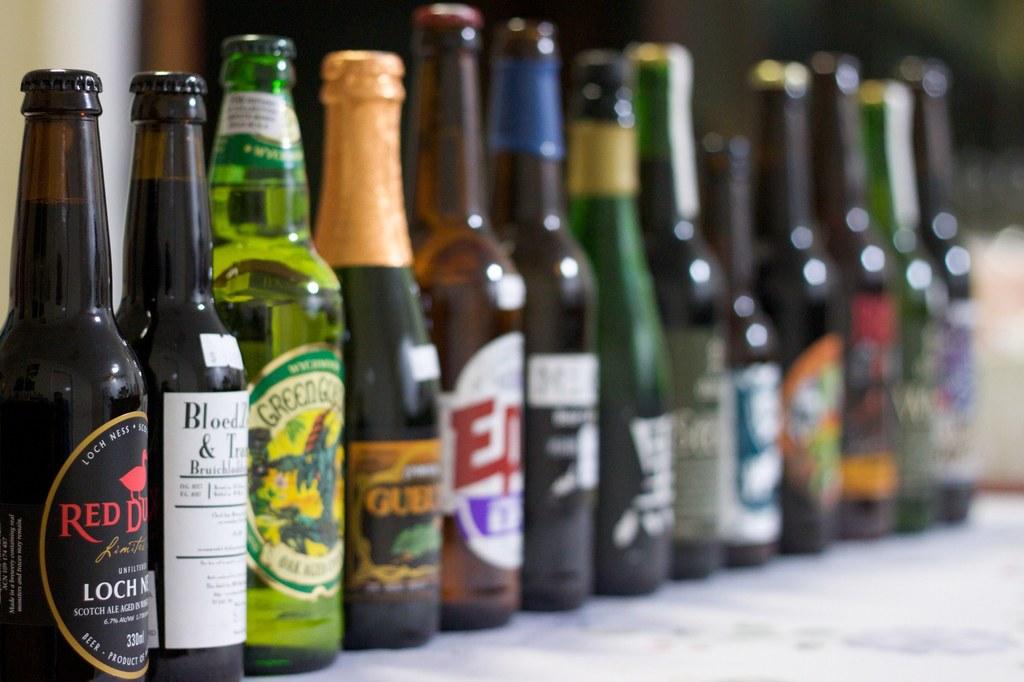What color is on the far left bottle?
Provide a short and direct response. Red. 